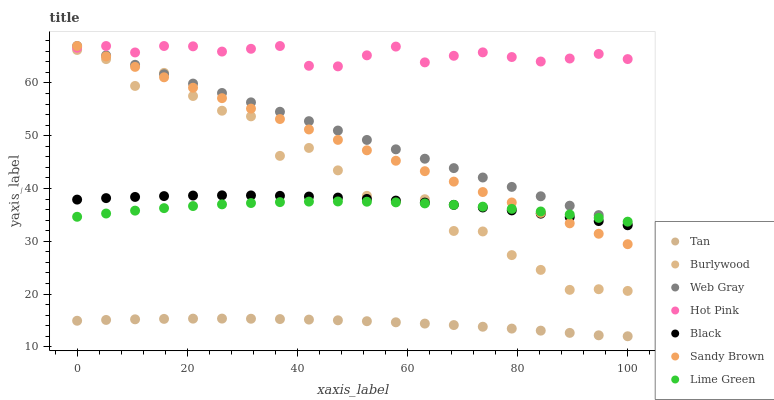Does Tan have the minimum area under the curve?
Answer yes or no. Yes. Does Hot Pink have the maximum area under the curve?
Answer yes or no. Yes. Does Burlywood have the minimum area under the curve?
Answer yes or no. No. Does Burlywood have the maximum area under the curve?
Answer yes or no. No. Is Web Gray the smoothest?
Answer yes or no. Yes. Is Burlywood the roughest?
Answer yes or no. Yes. Is Lime Green the smoothest?
Answer yes or no. No. Is Lime Green the roughest?
Answer yes or no. No. Does Tan have the lowest value?
Answer yes or no. Yes. Does Burlywood have the lowest value?
Answer yes or no. No. Does Sandy Brown have the highest value?
Answer yes or no. Yes. Does Burlywood have the highest value?
Answer yes or no. No. Is Black less than Web Gray?
Answer yes or no. Yes. Is Hot Pink greater than Black?
Answer yes or no. Yes. Does Burlywood intersect Lime Green?
Answer yes or no. Yes. Is Burlywood less than Lime Green?
Answer yes or no. No. Is Burlywood greater than Lime Green?
Answer yes or no. No. Does Black intersect Web Gray?
Answer yes or no. No. 